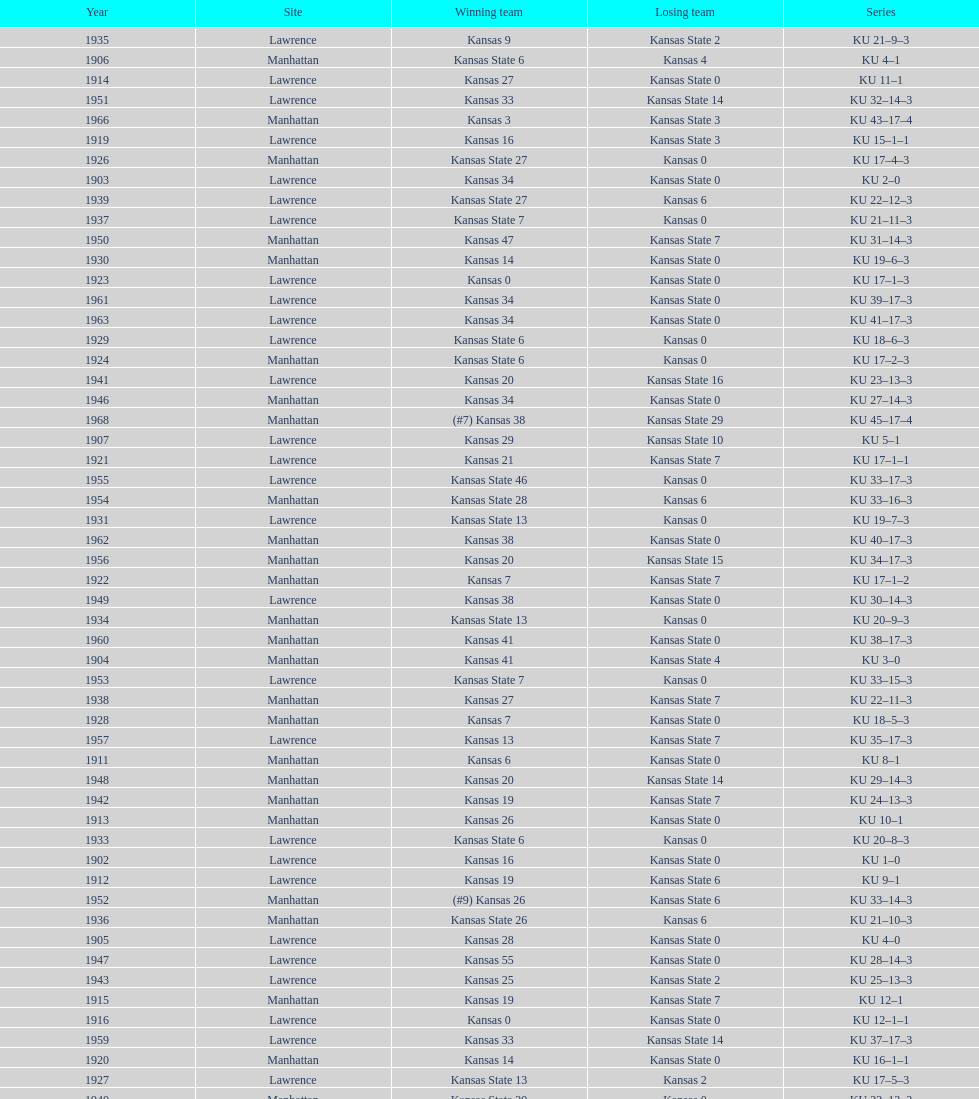What was the number of wins kansas state had in manhattan? 8. 